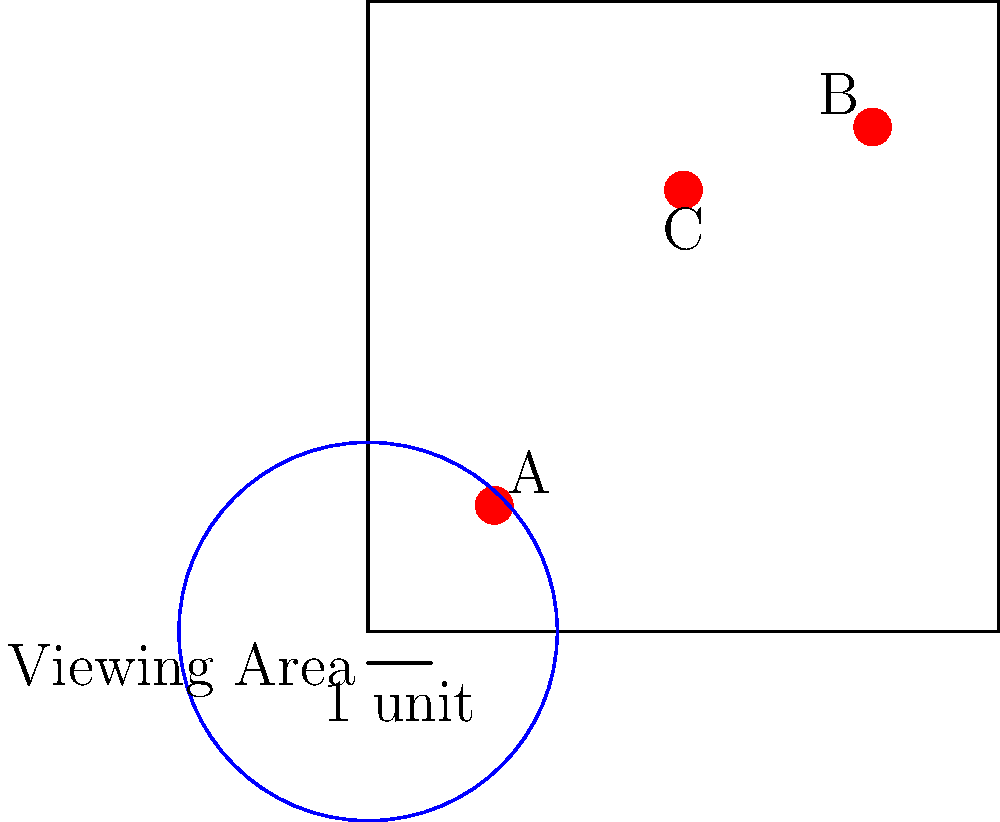Based on the map layout of motorcycle stunt ramps, where each unit represents 10 meters, what is the minimum safe viewing distance from the closest ramp to ensure you're not within the danger zone? Assume the danger zone extends 25 meters from each ramp. To solve this problem, we need to follow these steps:

1. Identify the closest ramp to the viewing area:
   - Ramp A is at (2,2)
   - Ramp B is at (8,8)
   - Ramp C is at (5,7)
   Ramp A is clearly the closest to the viewing area at (0,0).

2. Calculate the distance from the viewing area to Ramp A:
   Using the Pythagorean theorem: 
   $$d = \sqrt{(x_2-x_1)^2 + (y_2-y_1)^2}$$
   $$d = \sqrt{(2-0)^2 + (2-0)^2} = \sqrt{8} = 2\sqrt{2}$$ units

3. Convert units to meters:
   $2\sqrt{2}$ units * 10 meters/unit = $20\sqrt{2}$ meters

4. Calculate the safe viewing distance:
   Safe distance = Distance to ramp - Danger zone radius
   $$20\sqrt{2} - 25 \approx 3.28$$ meters

5. Since we can't have a negative safe distance, we round up to the nearest whole number for practicality.

Therefore, the minimum safe viewing distance is 4 meters from the edge of the viewing area.
Answer: 4 meters 